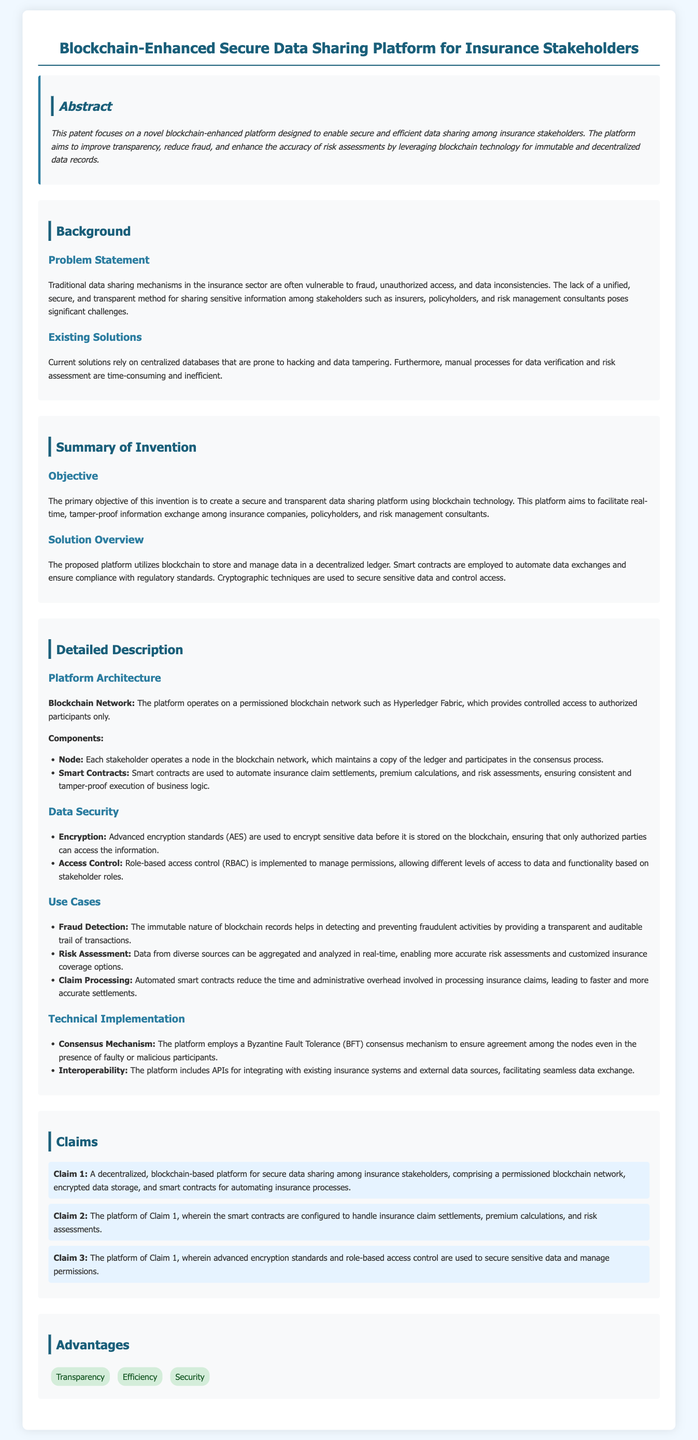What is the primary objective of the invention? The primary objective is to create a secure and transparent data sharing platform using blockchain technology.
Answer: secure and transparent data sharing platform What technology does the platform utilize for storing data? The document states that the platform utilizes blockchain to store and manage data.
Answer: blockchain What mechanism does the platform employ for consensus among nodes? The document specifies a Byzantine Fault Tolerance (BFT) consensus mechanism for agreement among nodes.
Answer: Byzantine Fault Tolerance (BFT) What is a key advantage listed for the platform? The document lists transparency as one of the key advantages of the platform.
Answer: Transparency What type of blockchain network does the platform operate on? The platform operates on a permissioned blockchain network, such as Hyperledger Fabric.
Answer: permissioned blockchain network How many claims are presented in the patent application? The document enumerates three claims in the claims section.
Answer: three What is used to secure sensitive data according to the document? Advanced encryption standards (AES) are used to encrypt sensitive data.
Answer: Advanced encryption standards (AES) What role do smart contracts play in the platform? Smart contracts are used to automate insurance claim settlements, premium calculations, and risk assessments.
Answer: automate insurance claim settlements, premium calculations, and risk assessments 